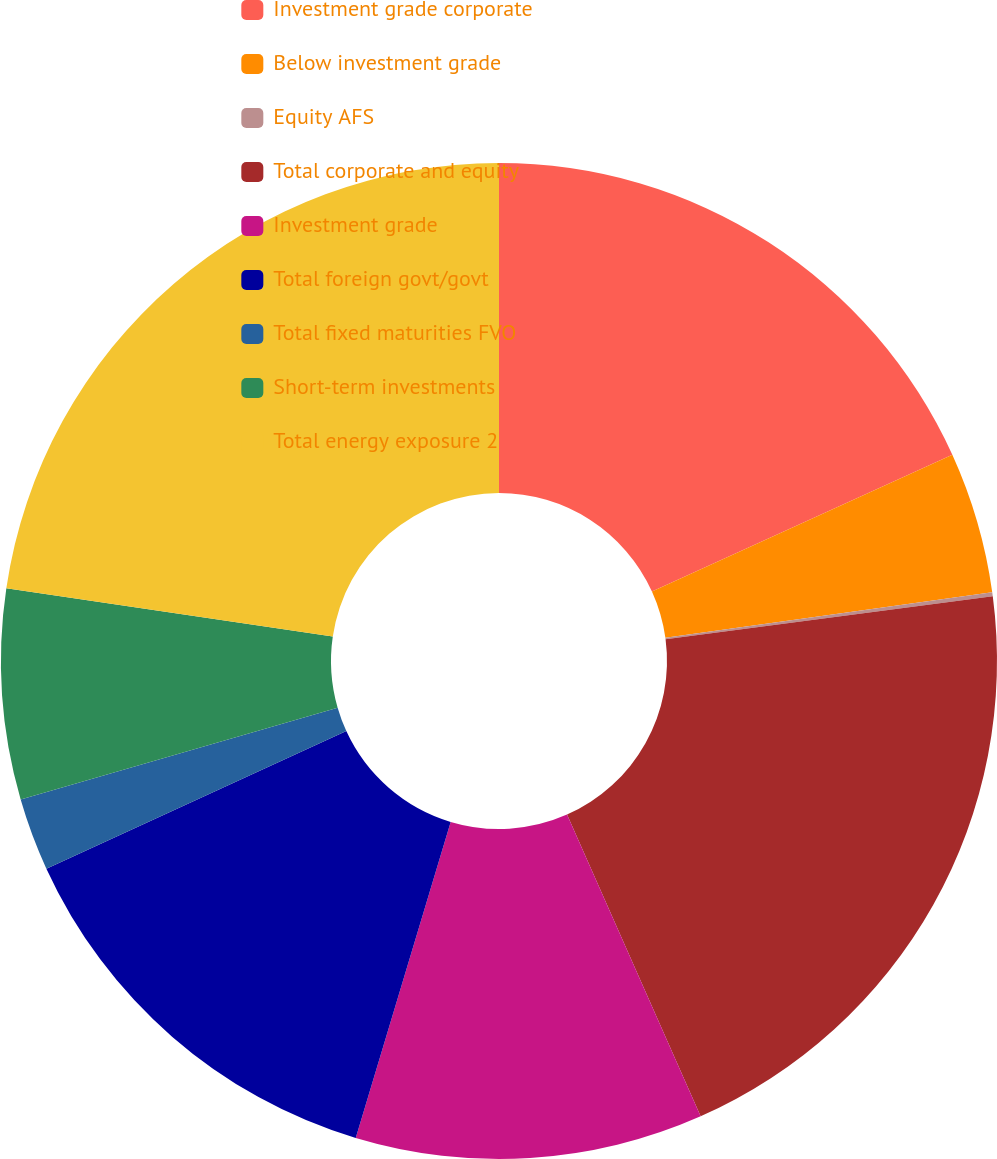Convert chart. <chart><loc_0><loc_0><loc_500><loc_500><pie_chart><fcel>Investment grade corporate<fcel>Below investment grade<fcel>Equity AFS<fcel>Total corporate and equity<fcel>Investment grade<fcel>Total foreign govt/govt<fcel>Total fixed maturities FVO<fcel>Short-term investments<fcel>Total energy exposure 2<nl><fcel>18.21%<fcel>4.59%<fcel>0.13%<fcel>20.44%<fcel>11.28%<fcel>13.51%<fcel>2.36%<fcel>6.82%<fcel>22.67%<nl></chart> 